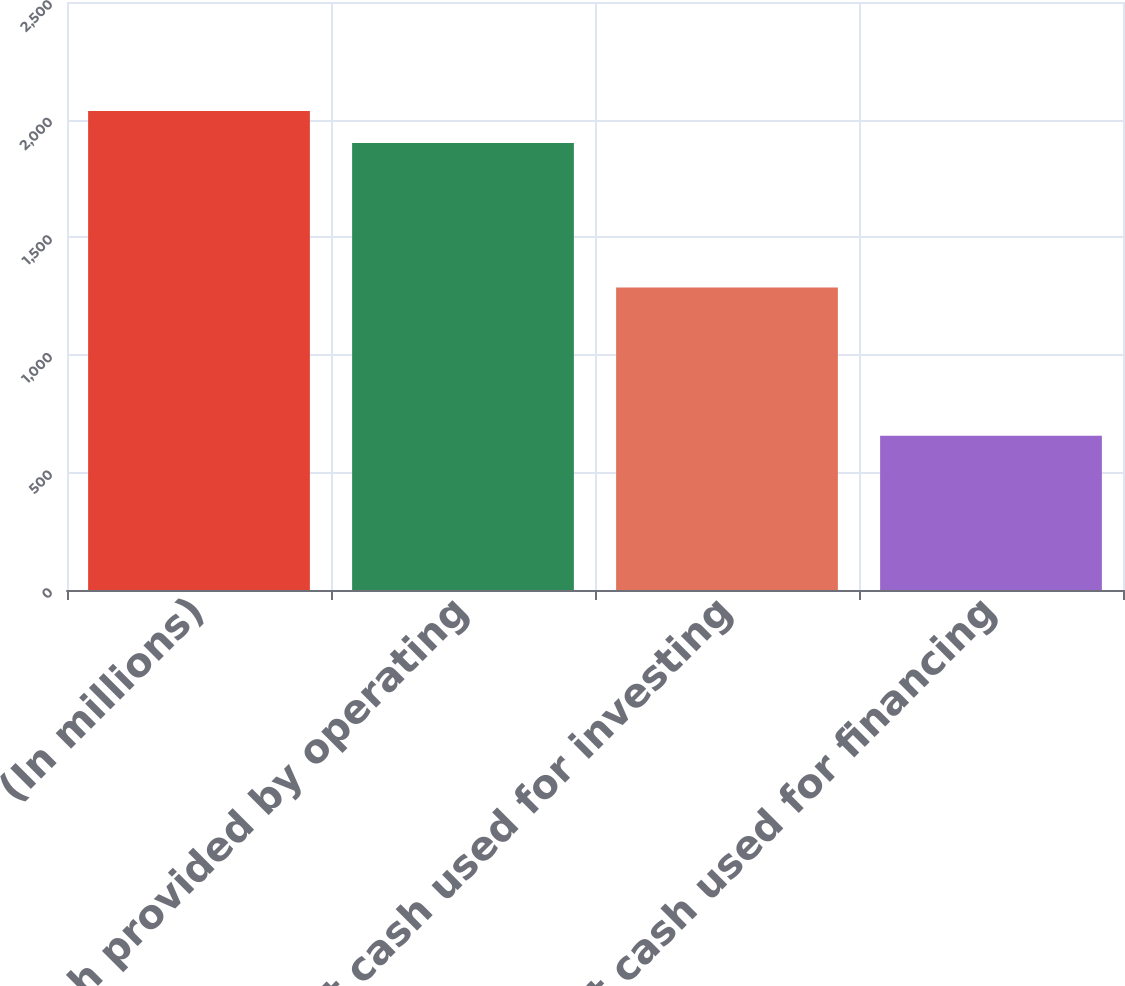Convert chart to OTSL. <chart><loc_0><loc_0><loc_500><loc_500><bar_chart><fcel>(In millions)<fcel>Net cash provided by operating<fcel>Net cash used for investing<fcel>Net cash used for financing<nl><fcel>2036.66<fcel>1900.5<fcel>1285.8<fcel>655.4<nl></chart> 